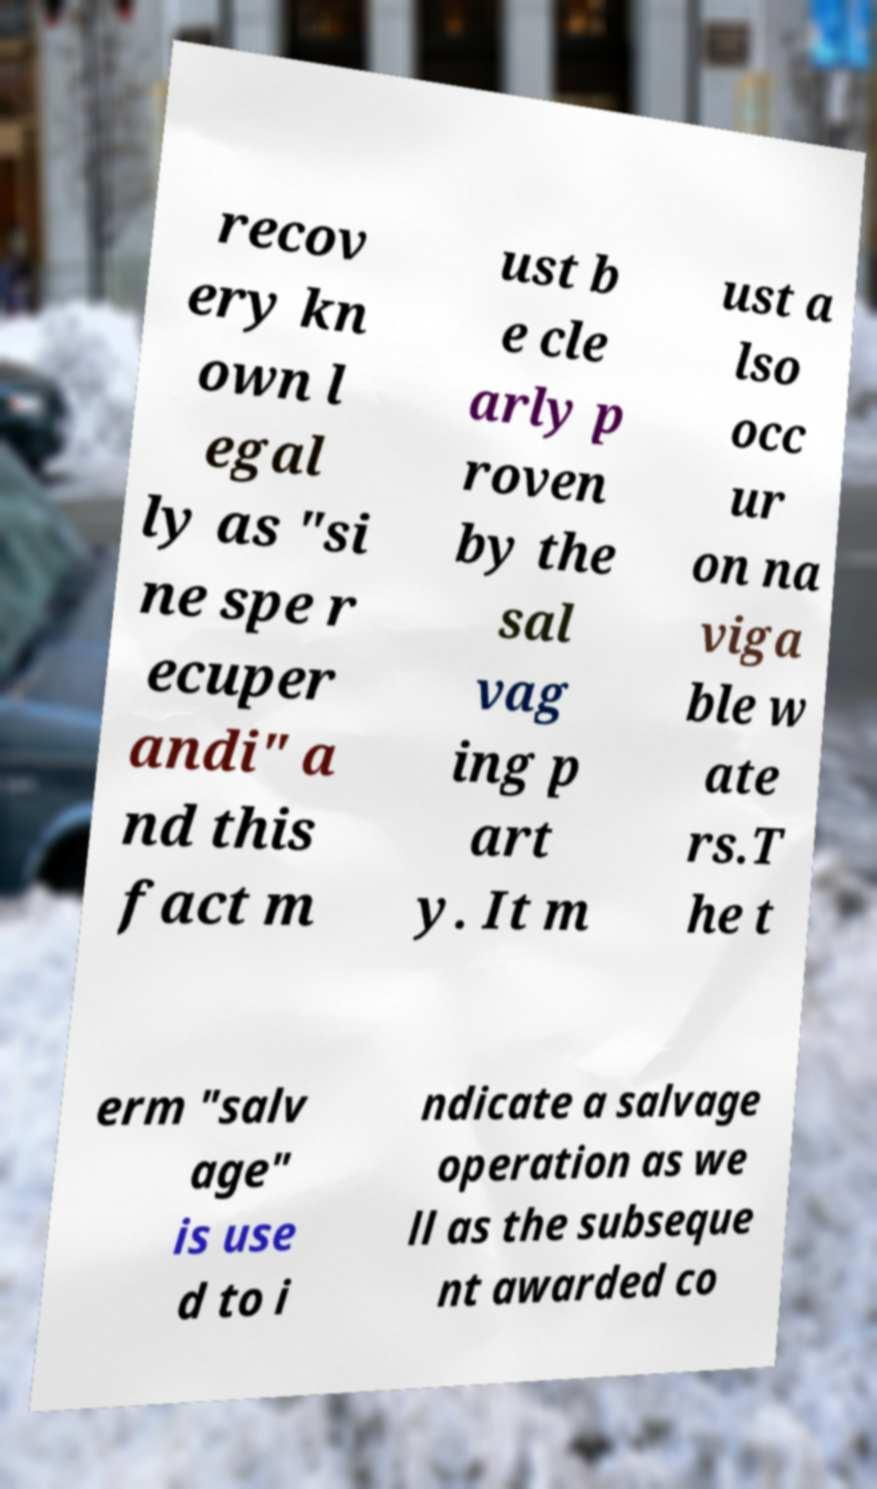Please identify and transcribe the text found in this image. recov ery kn own l egal ly as "si ne spe r ecuper andi" a nd this fact m ust b e cle arly p roven by the sal vag ing p art y. It m ust a lso occ ur on na viga ble w ate rs.T he t erm "salv age" is use d to i ndicate a salvage operation as we ll as the subseque nt awarded co 